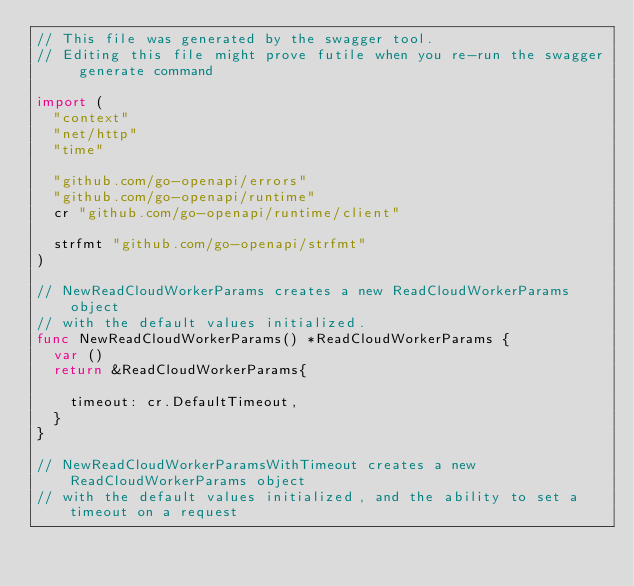Convert code to text. <code><loc_0><loc_0><loc_500><loc_500><_Go_>// This file was generated by the swagger tool.
// Editing this file might prove futile when you re-run the swagger generate command

import (
	"context"
	"net/http"
	"time"

	"github.com/go-openapi/errors"
	"github.com/go-openapi/runtime"
	cr "github.com/go-openapi/runtime/client"

	strfmt "github.com/go-openapi/strfmt"
)

// NewReadCloudWorkerParams creates a new ReadCloudWorkerParams object
// with the default values initialized.
func NewReadCloudWorkerParams() *ReadCloudWorkerParams {
	var ()
	return &ReadCloudWorkerParams{

		timeout: cr.DefaultTimeout,
	}
}

// NewReadCloudWorkerParamsWithTimeout creates a new ReadCloudWorkerParams object
// with the default values initialized, and the ability to set a timeout on a request</code> 